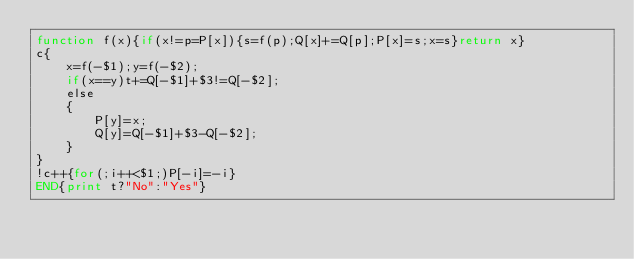<code> <loc_0><loc_0><loc_500><loc_500><_Awk_>function f(x){if(x!=p=P[x]){s=f(p);Q[x]+=Q[p];P[x]=s;x=s}return x}
c{
	x=f(-$1);y=f(-$2);
	if(x==y)t+=Q[-$1]+$3!=Q[-$2];
	else
	{
		P[y]=x;
		Q[y]=Q[-$1]+$3-Q[-$2];
	}
}
!c++{for(;i++<$1;)P[-i]=-i}
END{print t?"No":"Yes"}
</code> 